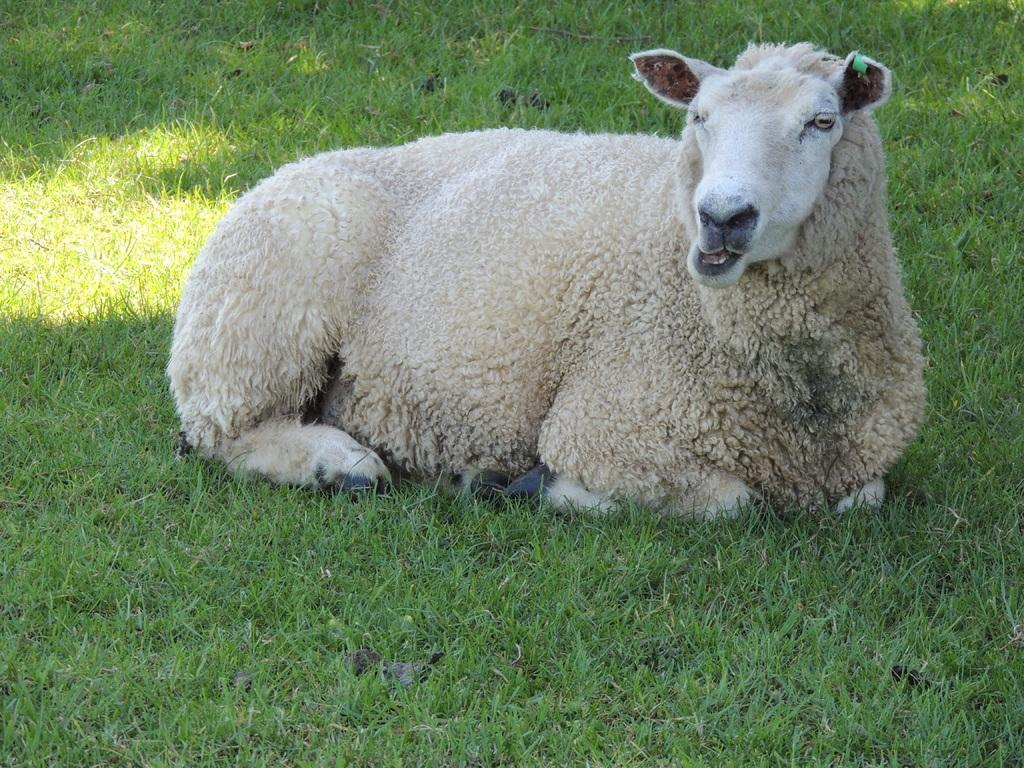What type of creature is present in the image? There is an animal in the image. Can you describe the color of the animal? The animal is in white and cream color. What type of environment is visible in the image? There is green grass visible in the image. What type of polish is the animal using in the image? There is no polish present in the image, and the animal is not using any polish. 